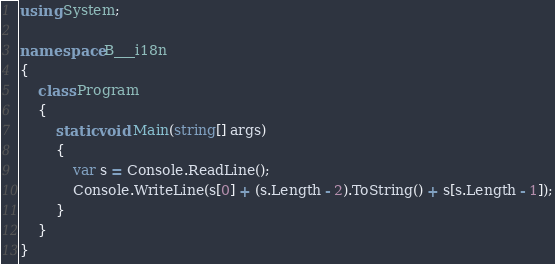<code> <loc_0><loc_0><loc_500><loc_500><_C#_>using System;

namespace B___i18n
{
    class Program
    {
        static void Main(string[] args)
        {
            var s = Console.ReadLine();
            Console.WriteLine(s[0] + (s.Length - 2).ToString() + s[s.Length - 1]);
        }
    }
}</code> 